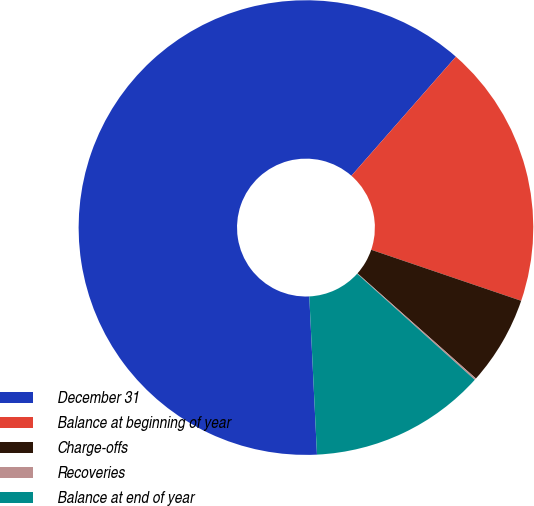<chart> <loc_0><loc_0><loc_500><loc_500><pie_chart><fcel>December 31<fcel>Balance at beginning of year<fcel>Charge-offs<fcel>Recoveries<fcel>Balance at end of year<nl><fcel>62.24%<fcel>18.76%<fcel>6.34%<fcel>0.12%<fcel>12.55%<nl></chart> 